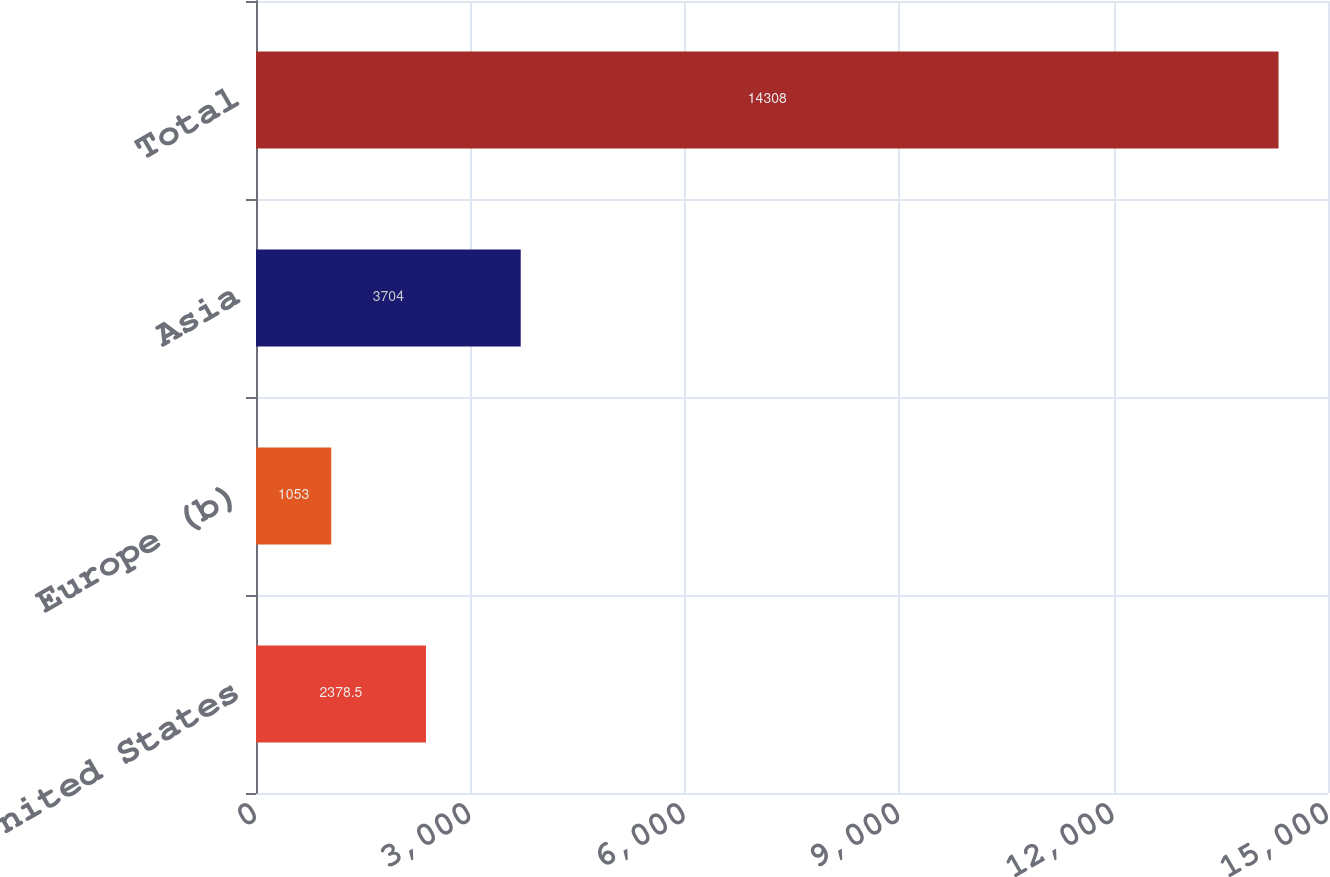<chart> <loc_0><loc_0><loc_500><loc_500><bar_chart><fcel>United States<fcel>Europe (b)<fcel>Asia<fcel>Total<nl><fcel>2378.5<fcel>1053<fcel>3704<fcel>14308<nl></chart> 